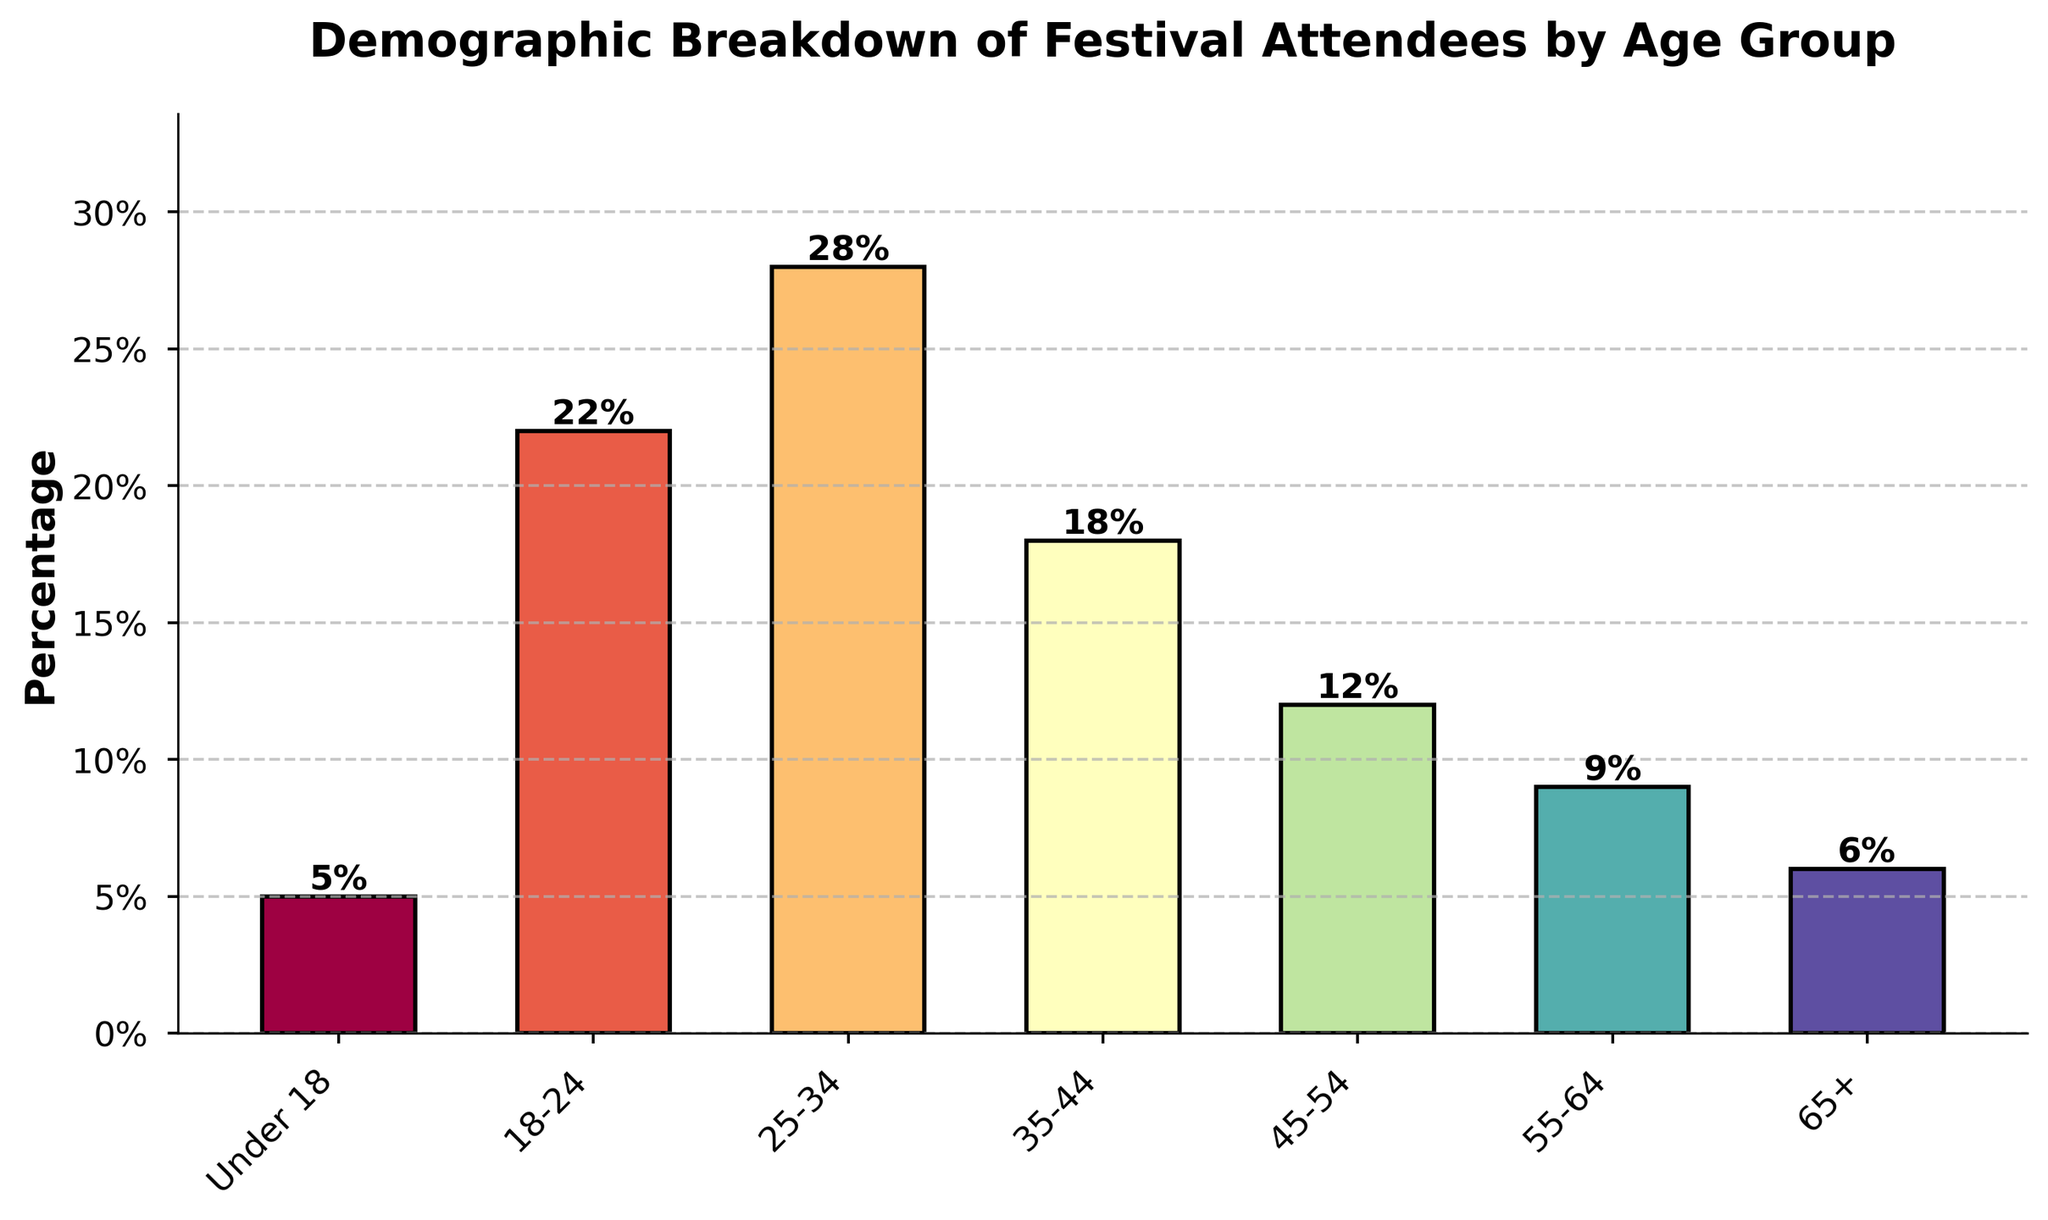What age group has the highest percentage of festival attendees? The bar with the highest height represents the age group 25-34, with a percentage of 28%.
Answer: 25-34 How does the percentage of attendees aged 45-54 compare to those aged 18-24? The bar for age group 18-24 has a percentage of 22%, whereas the age group 45-54 has a percentage of 12%. 22% is greater than 12%, so attendees aged 18-24 are more prevalent.
Answer: 18-24 has a higher percentage What is the average percentage of attendees for the age groups 25-34 and 35-44? Combine the percentages for age groups 25-34 and 35-44, which are 28% and 18%, respectively. The sum is 46%, and the average is 46% / 2 = 23%.
Answer: 23% Is the percentage of attendees aged 65+ greater than those under 18? The percentage of attendees aged 65+ is 6%, whereas the percentage of attendees under 18 is 5%. Therefore, 6% is slightly greater than 5%.
Answer: Yes What is the total percentage of attendees aged 18-24, 25-34, and 35-44 combined? The percentages for age groups 18-24, 25-34, and 35-44 are 22%, 28%, and 18%, respectively. Adding these together: 22% + 28% + 18% = 68%.
Answer: 68% How much lower is the percentage of attendees aged 55-64 compared to those aged 35-44? The percentage of attendees aged 35-44 is 18%, and the percentage for those aged 55-64 is 9%. The difference is 18% - 9% = 9%.
Answer: 9% lower What is the percentage difference between the youngest (under 18) and oldest (65+) age groups? The percentage for the youngest age group (under 18) is 5%, and for the oldest (65+) is 6%. The difference is 6% - 5% = 1%.
Answer: 1% difference Which age group represented by a bar in the middle in terms of height? Visually inspecting the chart, the 35-44 age group bar is neither the tallest nor the shortest. It represents a middle height of 18%.
Answer: 35-44 What is the cumulative percentage for age groups under 18 and those 55+? The percentage for under 18 is 5%. For 55-64, it's 9%, and for 65+, it's 6%. Adding these together: 5% + 9% + 6% = 20%.
Answer: 20% How does the percentage of the 25-34 age group compare to the combined percentage of the 55-64 and 65+ age groups? The percentage for the 25-34 age group is 28%. The combined percentage for 55-64 (9%) and 65+ (6%) is 9% + 6% = 15%. 28% is greater than 15%.
Answer: 25-34 has a higher percentage 